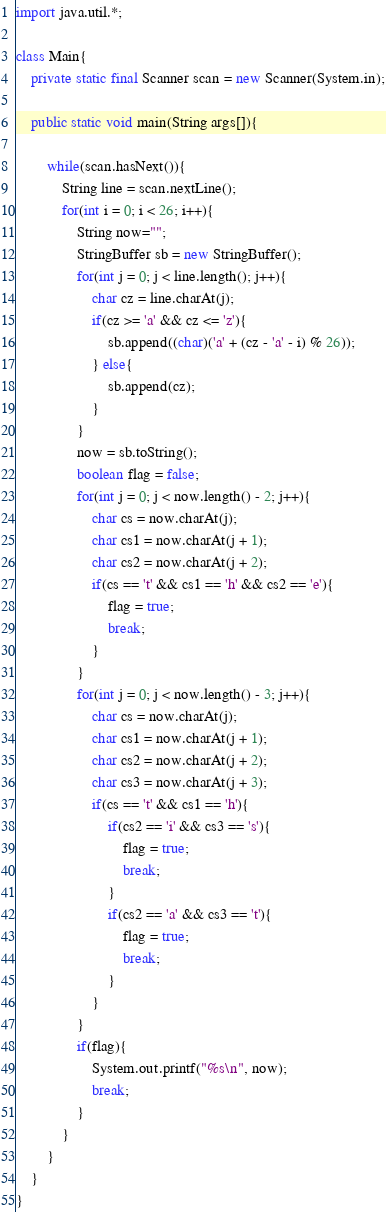Convert code to text. <code><loc_0><loc_0><loc_500><loc_500><_Java_>import java.util.*;

class Main{
	private static final Scanner scan = new Scanner(System.in);

    public static void main(String args[]){

        while(scan.hasNext()){
            String line = scan.nextLine();
            for(int i = 0; i < 26; i++){
                String now="";
				StringBuffer sb = new StringBuffer();
                for(int j = 0; j < line.length(); j++){
					char cz = line.charAt(j);
					if(cz >= 'a' && cz <= 'z'){
                        sb.append((char)('a' + (cz - 'a' - i) % 26));
                    } else{
						sb.append(cz);
					}
                }
				now = sb.toString();
				boolean flag = false;
                for(int j = 0; j < now.length() - 2; j++){
					char cs = now.charAt(j);
					char cs1 = now.charAt(j + 1);
					char cs2 = now.charAt(j + 2);
                    if(cs == 't' && cs1 == 'h' && cs2 == 'e'){
						flag = true;
						break;
					}
                }
                for(int j = 0; j < now.length() - 3; j++){
					char cs = now.charAt(j);
					char cs1 = now.charAt(j + 1);
					char cs2 = now.charAt(j + 2);
					char cs3 = now.charAt(j + 3);
                    if(cs == 't' && cs1 == 'h'){
                        if(cs2 == 'i' && cs3 == 's'){
							flag = true;
							break;
						}
                        if(cs2 == 'a' && cs3 == 't'){
							flag = true;
							break;
						}
                    }
                }
                if(flag){
                    System.out.printf("%s\n", now);
                    break;
                }
            }
        }
    }
}</code> 